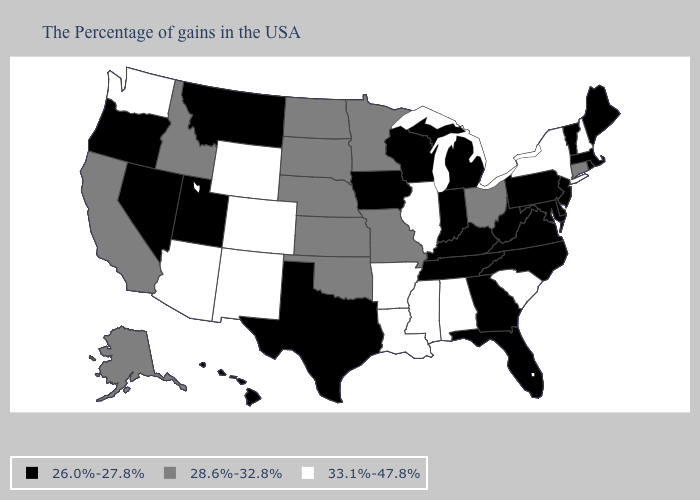Which states hav the highest value in the MidWest?
Concise answer only. Illinois. Does Louisiana have the highest value in the USA?
Short answer required. Yes. What is the value of Massachusetts?
Be succinct. 26.0%-27.8%. What is the value of California?
Answer briefly. 28.6%-32.8%. Which states have the lowest value in the USA?
Write a very short answer. Maine, Massachusetts, Rhode Island, Vermont, New Jersey, Delaware, Maryland, Pennsylvania, Virginia, North Carolina, West Virginia, Florida, Georgia, Michigan, Kentucky, Indiana, Tennessee, Wisconsin, Iowa, Texas, Utah, Montana, Nevada, Oregon, Hawaii. What is the value of Minnesota?
Short answer required. 28.6%-32.8%. Which states have the lowest value in the USA?
Concise answer only. Maine, Massachusetts, Rhode Island, Vermont, New Jersey, Delaware, Maryland, Pennsylvania, Virginia, North Carolina, West Virginia, Florida, Georgia, Michigan, Kentucky, Indiana, Tennessee, Wisconsin, Iowa, Texas, Utah, Montana, Nevada, Oregon, Hawaii. Does Florida have the lowest value in the South?
Keep it brief. Yes. Name the states that have a value in the range 28.6%-32.8%?
Concise answer only. Connecticut, Ohio, Missouri, Minnesota, Kansas, Nebraska, Oklahoma, South Dakota, North Dakota, Idaho, California, Alaska. Name the states that have a value in the range 33.1%-47.8%?
Concise answer only. New Hampshire, New York, South Carolina, Alabama, Illinois, Mississippi, Louisiana, Arkansas, Wyoming, Colorado, New Mexico, Arizona, Washington. Which states have the highest value in the USA?
Give a very brief answer. New Hampshire, New York, South Carolina, Alabama, Illinois, Mississippi, Louisiana, Arkansas, Wyoming, Colorado, New Mexico, Arizona, Washington. What is the value of South Dakota?
Be succinct. 28.6%-32.8%. Name the states that have a value in the range 33.1%-47.8%?
Concise answer only. New Hampshire, New York, South Carolina, Alabama, Illinois, Mississippi, Louisiana, Arkansas, Wyoming, Colorado, New Mexico, Arizona, Washington. What is the highest value in the USA?
Be succinct. 33.1%-47.8%. Which states have the highest value in the USA?
Quick response, please. New Hampshire, New York, South Carolina, Alabama, Illinois, Mississippi, Louisiana, Arkansas, Wyoming, Colorado, New Mexico, Arizona, Washington. 